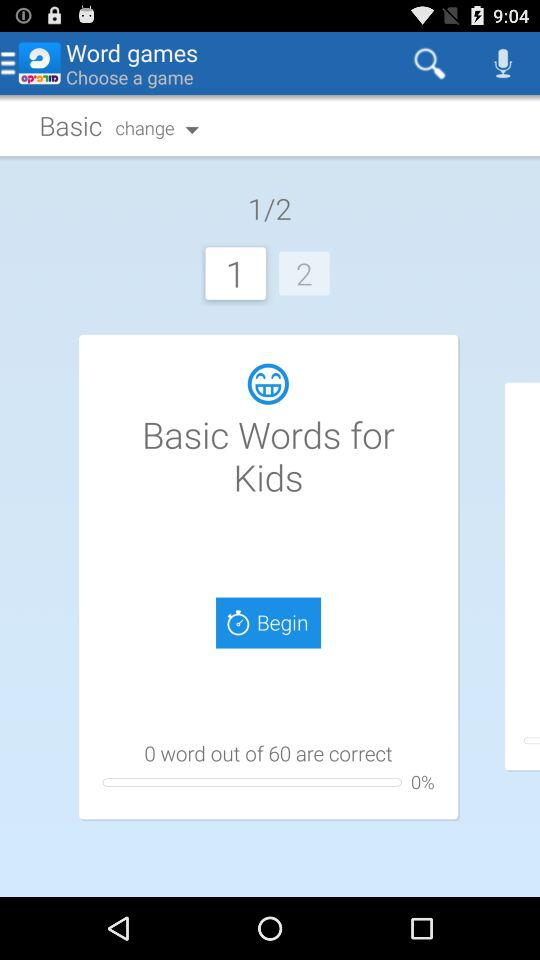How many words are correct out of 60? There are 0 words correct out of 60. 